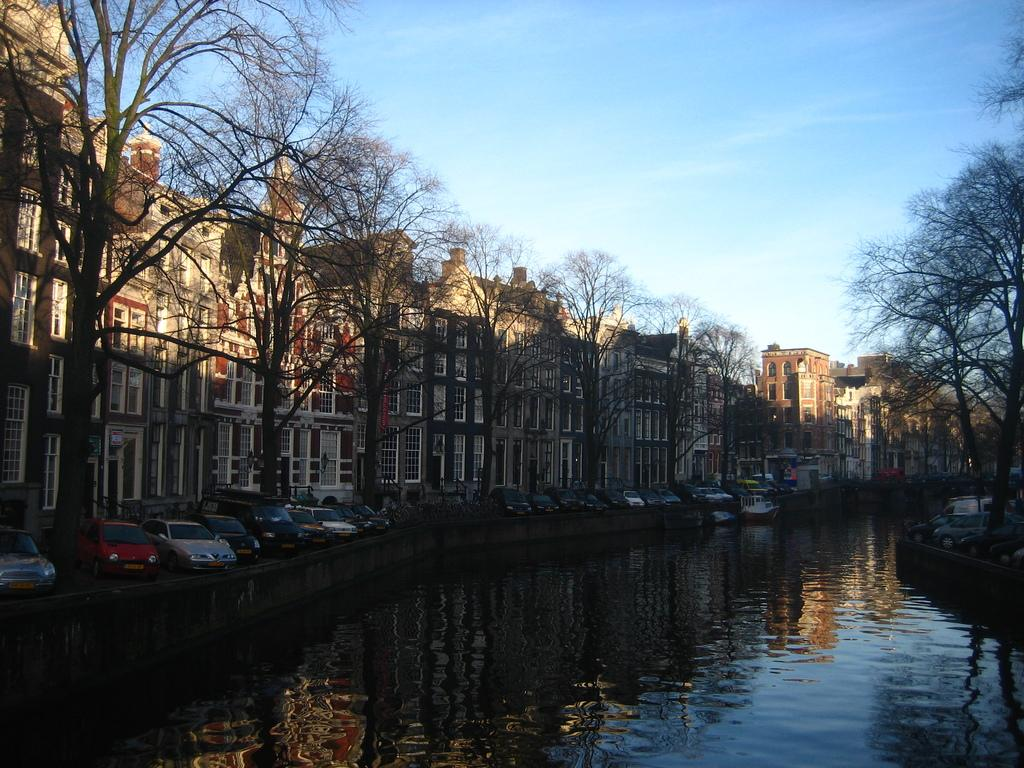What type of structures can be seen in the image? There are buildings with windows in the image. What is the condition of the trees in the image? Dry trees are present in the image. What type of transportation is visible in the image? Boats and vehicles are visible in the image. What natural element is present in the image? There is water visible in the image. What is visible in the sky in the image? The sky is visible in the image, and clouds are present. What type of brass instrument is being played by the person in jail in the image? There is no brass instrument or person in jail present in the image. What type of cloth is draped over the dry trees in the image? There is no cloth draped over the dry trees in the image; the trees are dry and visible as they are. 